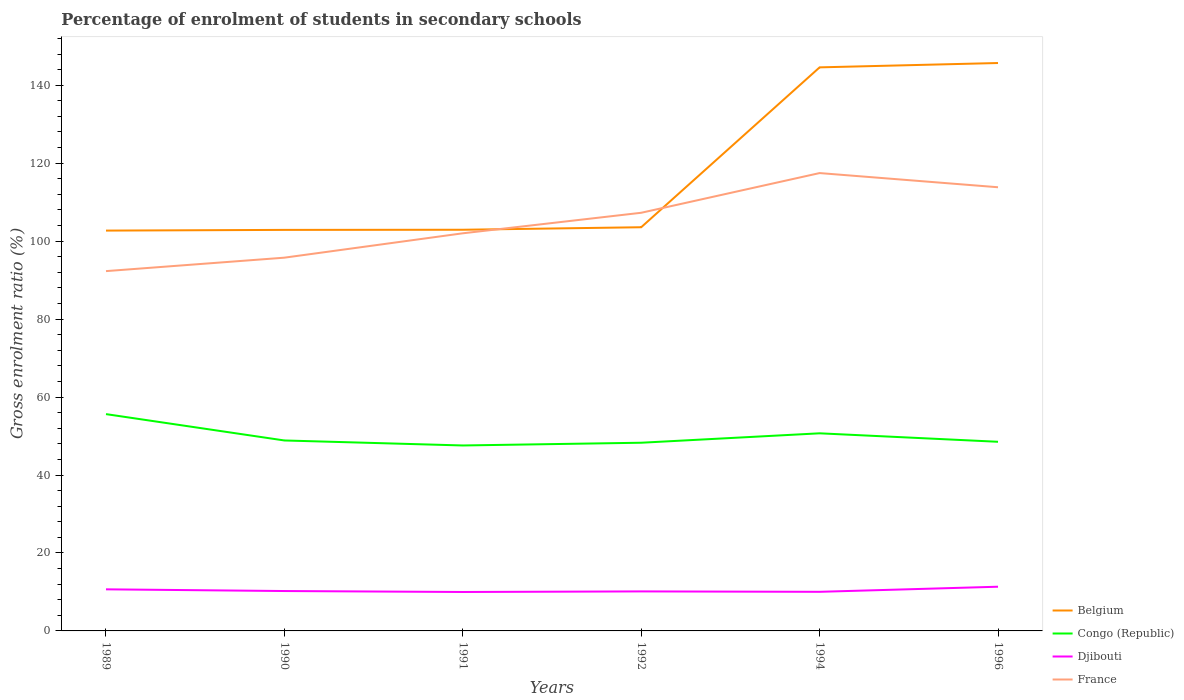How many different coloured lines are there?
Provide a succinct answer. 4. Does the line corresponding to Belgium intersect with the line corresponding to Djibouti?
Offer a very short reply. No. Is the number of lines equal to the number of legend labels?
Ensure brevity in your answer.  Yes. Across all years, what is the maximum percentage of students enrolled in secondary schools in Congo (Republic)?
Give a very brief answer. 47.58. In which year was the percentage of students enrolled in secondary schools in Djibouti maximum?
Your response must be concise. 1991. What is the total percentage of students enrolled in secondary schools in Djibouti in the graph?
Your answer should be very brief. -1.31. What is the difference between the highest and the second highest percentage of students enrolled in secondary schools in Djibouti?
Provide a short and direct response. 1.35. What is the difference between the highest and the lowest percentage of students enrolled in secondary schools in Belgium?
Provide a succinct answer. 2. How many years are there in the graph?
Your answer should be very brief. 6. What is the difference between two consecutive major ticks on the Y-axis?
Provide a short and direct response. 20. Are the values on the major ticks of Y-axis written in scientific E-notation?
Ensure brevity in your answer.  No. How many legend labels are there?
Your response must be concise. 4. What is the title of the graph?
Your answer should be very brief. Percentage of enrolment of students in secondary schools. Does "Poland" appear as one of the legend labels in the graph?
Offer a terse response. No. What is the label or title of the Y-axis?
Ensure brevity in your answer.  Gross enrolment ratio (%). What is the Gross enrolment ratio (%) of Belgium in 1989?
Ensure brevity in your answer.  102.7. What is the Gross enrolment ratio (%) in Congo (Republic) in 1989?
Provide a succinct answer. 55.62. What is the Gross enrolment ratio (%) in Djibouti in 1989?
Your answer should be compact. 10.67. What is the Gross enrolment ratio (%) of France in 1989?
Your response must be concise. 92.31. What is the Gross enrolment ratio (%) in Belgium in 1990?
Your response must be concise. 102.88. What is the Gross enrolment ratio (%) in Congo (Republic) in 1990?
Offer a very short reply. 48.86. What is the Gross enrolment ratio (%) of Djibouti in 1990?
Make the answer very short. 10.23. What is the Gross enrolment ratio (%) of France in 1990?
Your response must be concise. 95.76. What is the Gross enrolment ratio (%) of Belgium in 1991?
Ensure brevity in your answer.  102.92. What is the Gross enrolment ratio (%) in Congo (Republic) in 1991?
Provide a succinct answer. 47.58. What is the Gross enrolment ratio (%) of Djibouti in 1991?
Your answer should be compact. 9.99. What is the Gross enrolment ratio (%) of France in 1991?
Provide a succinct answer. 102.01. What is the Gross enrolment ratio (%) in Belgium in 1992?
Keep it short and to the point. 103.57. What is the Gross enrolment ratio (%) of Congo (Republic) in 1992?
Provide a succinct answer. 48.28. What is the Gross enrolment ratio (%) in Djibouti in 1992?
Your answer should be very brief. 10.14. What is the Gross enrolment ratio (%) of France in 1992?
Provide a short and direct response. 107.27. What is the Gross enrolment ratio (%) of Belgium in 1994?
Provide a succinct answer. 144.58. What is the Gross enrolment ratio (%) of Congo (Republic) in 1994?
Your response must be concise. 50.69. What is the Gross enrolment ratio (%) in Djibouti in 1994?
Provide a short and direct response. 10.03. What is the Gross enrolment ratio (%) of France in 1994?
Offer a very short reply. 117.46. What is the Gross enrolment ratio (%) of Belgium in 1996?
Make the answer very short. 145.69. What is the Gross enrolment ratio (%) of Congo (Republic) in 1996?
Ensure brevity in your answer.  48.52. What is the Gross enrolment ratio (%) in Djibouti in 1996?
Keep it short and to the point. 11.34. What is the Gross enrolment ratio (%) in France in 1996?
Ensure brevity in your answer.  113.82. Across all years, what is the maximum Gross enrolment ratio (%) in Belgium?
Ensure brevity in your answer.  145.69. Across all years, what is the maximum Gross enrolment ratio (%) of Congo (Republic)?
Provide a short and direct response. 55.62. Across all years, what is the maximum Gross enrolment ratio (%) of Djibouti?
Keep it short and to the point. 11.34. Across all years, what is the maximum Gross enrolment ratio (%) of France?
Offer a terse response. 117.46. Across all years, what is the minimum Gross enrolment ratio (%) in Belgium?
Offer a terse response. 102.7. Across all years, what is the minimum Gross enrolment ratio (%) in Congo (Republic)?
Ensure brevity in your answer.  47.58. Across all years, what is the minimum Gross enrolment ratio (%) of Djibouti?
Your answer should be very brief. 9.99. Across all years, what is the minimum Gross enrolment ratio (%) in France?
Make the answer very short. 92.31. What is the total Gross enrolment ratio (%) in Belgium in the graph?
Offer a very short reply. 702.34. What is the total Gross enrolment ratio (%) in Congo (Republic) in the graph?
Your answer should be very brief. 299.55. What is the total Gross enrolment ratio (%) of Djibouti in the graph?
Offer a very short reply. 62.41. What is the total Gross enrolment ratio (%) of France in the graph?
Offer a terse response. 628.63. What is the difference between the Gross enrolment ratio (%) of Belgium in 1989 and that in 1990?
Offer a very short reply. -0.18. What is the difference between the Gross enrolment ratio (%) of Congo (Republic) in 1989 and that in 1990?
Make the answer very short. 6.76. What is the difference between the Gross enrolment ratio (%) in Djibouti in 1989 and that in 1990?
Your response must be concise. 0.44. What is the difference between the Gross enrolment ratio (%) in France in 1989 and that in 1990?
Provide a succinct answer. -3.45. What is the difference between the Gross enrolment ratio (%) of Belgium in 1989 and that in 1991?
Offer a terse response. -0.21. What is the difference between the Gross enrolment ratio (%) of Congo (Republic) in 1989 and that in 1991?
Provide a short and direct response. 8.04. What is the difference between the Gross enrolment ratio (%) of Djibouti in 1989 and that in 1991?
Keep it short and to the point. 0.68. What is the difference between the Gross enrolment ratio (%) in France in 1989 and that in 1991?
Offer a very short reply. -9.7. What is the difference between the Gross enrolment ratio (%) in Belgium in 1989 and that in 1992?
Give a very brief answer. -0.86. What is the difference between the Gross enrolment ratio (%) of Congo (Republic) in 1989 and that in 1992?
Your answer should be compact. 7.34. What is the difference between the Gross enrolment ratio (%) of Djibouti in 1989 and that in 1992?
Offer a very short reply. 0.53. What is the difference between the Gross enrolment ratio (%) in France in 1989 and that in 1992?
Provide a succinct answer. -14.97. What is the difference between the Gross enrolment ratio (%) of Belgium in 1989 and that in 1994?
Your answer should be compact. -41.87. What is the difference between the Gross enrolment ratio (%) of Congo (Republic) in 1989 and that in 1994?
Your answer should be compact. 4.93. What is the difference between the Gross enrolment ratio (%) of Djibouti in 1989 and that in 1994?
Your answer should be compact. 0.64. What is the difference between the Gross enrolment ratio (%) of France in 1989 and that in 1994?
Your answer should be compact. -25.15. What is the difference between the Gross enrolment ratio (%) of Belgium in 1989 and that in 1996?
Your answer should be very brief. -42.99. What is the difference between the Gross enrolment ratio (%) in Congo (Republic) in 1989 and that in 1996?
Offer a terse response. 7.09. What is the difference between the Gross enrolment ratio (%) in Djibouti in 1989 and that in 1996?
Provide a succinct answer. -0.67. What is the difference between the Gross enrolment ratio (%) in France in 1989 and that in 1996?
Your answer should be very brief. -21.52. What is the difference between the Gross enrolment ratio (%) of Belgium in 1990 and that in 1991?
Make the answer very short. -0.04. What is the difference between the Gross enrolment ratio (%) in Congo (Republic) in 1990 and that in 1991?
Offer a very short reply. 1.28. What is the difference between the Gross enrolment ratio (%) of Djibouti in 1990 and that in 1991?
Your response must be concise. 0.24. What is the difference between the Gross enrolment ratio (%) in France in 1990 and that in 1991?
Keep it short and to the point. -6.25. What is the difference between the Gross enrolment ratio (%) in Belgium in 1990 and that in 1992?
Ensure brevity in your answer.  -0.68. What is the difference between the Gross enrolment ratio (%) in Congo (Republic) in 1990 and that in 1992?
Keep it short and to the point. 0.58. What is the difference between the Gross enrolment ratio (%) in Djibouti in 1990 and that in 1992?
Ensure brevity in your answer.  0.1. What is the difference between the Gross enrolment ratio (%) of France in 1990 and that in 1992?
Give a very brief answer. -11.52. What is the difference between the Gross enrolment ratio (%) in Belgium in 1990 and that in 1994?
Give a very brief answer. -41.7. What is the difference between the Gross enrolment ratio (%) in Congo (Republic) in 1990 and that in 1994?
Offer a very short reply. -1.83. What is the difference between the Gross enrolment ratio (%) of Djibouti in 1990 and that in 1994?
Keep it short and to the point. 0.2. What is the difference between the Gross enrolment ratio (%) in France in 1990 and that in 1994?
Your response must be concise. -21.7. What is the difference between the Gross enrolment ratio (%) in Belgium in 1990 and that in 1996?
Ensure brevity in your answer.  -42.81. What is the difference between the Gross enrolment ratio (%) in Congo (Republic) in 1990 and that in 1996?
Provide a short and direct response. 0.34. What is the difference between the Gross enrolment ratio (%) in Djibouti in 1990 and that in 1996?
Give a very brief answer. -1.11. What is the difference between the Gross enrolment ratio (%) in France in 1990 and that in 1996?
Make the answer very short. -18.07. What is the difference between the Gross enrolment ratio (%) in Belgium in 1991 and that in 1992?
Make the answer very short. -0.65. What is the difference between the Gross enrolment ratio (%) of Congo (Republic) in 1991 and that in 1992?
Offer a very short reply. -0.7. What is the difference between the Gross enrolment ratio (%) of Djibouti in 1991 and that in 1992?
Your response must be concise. -0.15. What is the difference between the Gross enrolment ratio (%) of France in 1991 and that in 1992?
Provide a short and direct response. -5.26. What is the difference between the Gross enrolment ratio (%) of Belgium in 1991 and that in 1994?
Your answer should be compact. -41.66. What is the difference between the Gross enrolment ratio (%) in Congo (Republic) in 1991 and that in 1994?
Provide a succinct answer. -3.12. What is the difference between the Gross enrolment ratio (%) of Djibouti in 1991 and that in 1994?
Provide a short and direct response. -0.04. What is the difference between the Gross enrolment ratio (%) of France in 1991 and that in 1994?
Provide a short and direct response. -15.45. What is the difference between the Gross enrolment ratio (%) of Belgium in 1991 and that in 1996?
Provide a short and direct response. -42.77. What is the difference between the Gross enrolment ratio (%) of Congo (Republic) in 1991 and that in 1996?
Your answer should be compact. -0.95. What is the difference between the Gross enrolment ratio (%) in Djibouti in 1991 and that in 1996?
Provide a succinct answer. -1.35. What is the difference between the Gross enrolment ratio (%) in France in 1991 and that in 1996?
Offer a terse response. -11.81. What is the difference between the Gross enrolment ratio (%) of Belgium in 1992 and that in 1994?
Your response must be concise. -41.01. What is the difference between the Gross enrolment ratio (%) of Congo (Republic) in 1992 and that in 1994?
Your answer should be very brief. -2.41. What is the difference between the Gross enrolment ratio (%) of Djibouti in 1992 and that in 1994?
Ensure brevity in your answer.  0.1. What is the difference between the Gross enrolment ratio (%) in France in 1992 and that in 1994?
Your response must be concise. -10.19. What is the difference between the Gross enrolment ratio (%) in Belgium in 1992 and that in 1996?
Ensure brevity in your answer.  -42.13. What is the difference between the Gross enrolment ratio (%) of Congo (Republic) in 1992 and that in 1996?
Make the answer very short. -0.25. What is the difference between the Gross enrolment ratio (%) in Djibouti in 1992 and that in 1996?
Offer a very short reply. -1.2. What is the difference between the Gross enrolment ratio (%) in France in 1992 and that in 1996?
Offer a very short reply. -6.55. What is the difference between the Gross enrolment ratio (%) of Belgium in 1994 and that in 1996?
Offer a terse response. -1.11. What is the difference between the Gross enrolment ratio (%) in Congo (Republic) in 1994 and that in 1996?
Keep it short and to the point. 2.17. What is the difference between the Gross enrolment ratio (%) in Djibouti in 1994 and that in 1996?
Your answer should be very brief. -1.31. What is the difference between the Gross enrolment ratio (%) in France in 1994 and that in 1996?
Ensure brevity in your answer.  3.64. What is the difference between the Gross enrolment ratio (%) in Belgium in 1989 and the Gross enrolment ratio (%) in Congo (Republic) in 1990?
Give a very brief answer. 53.84. What is the difference between the Gross enrolment ratio (%) in Belgium in 1989 and the Gross enrolment ratio (%) in Djibouti in 1990?
Your response must be concise. 92.47. What is the difference between the Gross enrolment ratio (%) of Belgium in 1989 and the Gross enrolment ratio (%) of France in 1990?
Provide a short and direct response. 6.95. What is the difference between the Gross enrolment ratio (%) of Congo (Republic) in 1989 and the Gross enrolment ratio (%) of Djibouti in 1990?
Keep it short and to the point. 45.38. What is the difference between the Gross enrolment ratio (%) in Congo (Republic) in 1989 and the Gross enrolment ratio (%) in France in 1990?
Your response must be concise. -40.14. What is the difference between the Gross enrolment ratio (%) of Djibouti in 1989 and the Gross enrolment ratio (%) of France in 1990?
Provide a short and direct response. -85.09. What is the difference between the Gross enrolment ratio (%) in Belgium in 1989 and the Gross enrolment ratio (%) in Congo (Republic) in 1991?
Ensure brevity in your answer.  55.13. What is the difference between the Gross enrolment ratio (%) of Belgium in 1989 and the Gross enrolment ratio (%) of Djibouti in 1991?
Your answer should be compact. 92.71. What is the difference between the Gross enrolment ratio (%) of Belgium in 1989 and the Gross enrolment ratio (%) of France in 1991?
Your answer should be compact. 0.7. What is the difference between the Gross enrolment ratio (%) of Congo (Republic) in 1989 and the Gross enrolment ratio (%) of Djibouti in 1991?
Ensure brevity in your answer.  45.63. What is the difference between the Gross enrolment ratio (%) in Congo (Republic) in 1989 and the Gross enrolment ratio (%) in France in 1991?
Your answer should be very brief. -46.39. What is the difference between the Gross enrolment ratio (%) in Djibouti in 1989 and the Gross enrolment ratio (%) in France in 1991?
Make the answer very short. -91.34. What is the difference between the Gross enrolment ratio (%) in Belgium in 1989 and the Gross enrolment ratio (%) in Congo (Republic) in 1992?
Provide a short and direct response. 54.42. What is the difference between the Gross enrolment ratio (%) in Belgium in 1989 and the Gross enrolment ratio (%) in Djibouti in 1992?
Provide a short and direct response. 92.57. What is the difference between the Gross enrolment ratio (%) of Belgium in 1989 and the Gross enrolment ratio (%) of France in 1992?
Ensure brevity in your answer.  -4.57. What is the difference between the Gross enrolment ratio (%) in Congo (Republic) in 1989 and the Gross enrolment ratio (%) in Djibouti in 1992?
Make the answer very short. 45.48. What is the difference between the Gross enrolment ratio (%) of Congo (Republic) in 1989 and the Gross enrolment ratio (%) of France in 1992?
Make the answer very short. -51.65. What is the difference between the Gross enrolment ratio (%) in Djibouti in 1989 and the Gross enrolment ratio (%) in France in 1992?
Give a very brief answer. -96.6. What is the difference between the Gross enrolment ratio (%) of Belgium in 1989 and the Gross enrolment ratio (%) of Congo (Republic) in 1994?
Keep it short and to the point. 52.01. What is the difference between the Gross enrolment ratio (%) in Belgium in 1989 and the Gross enrolment ratio (%) in Djibouti in 1994?
Your response must be concise. 92.67. What is the difference between the Gross enrolment ratio (%) in Belgium in 1989 and the Gross enrolment ratio (%) in France in 1994?
Provide a succinct answer. -14.76. What is the difference between the Gross enrolment ratio (%) of Congo (Republic) in 1989 and the Gross enrolment ratio (%) of Djibouti in 1994?
Your answer should be very brief. 45.59. What is the difference between the Gross enrolment ratio (%) of Congo (Republic) in 1989 and the Gross enrolment ratio (%) of France in 1994?
Provide a succinct answer. -61.84. What is the difference between the Gross enrolment ratio (%) in Djibouti in 1989 and the Gross enrolment ratio (%) in France in 1994?
Provide a short and direct response. -106.79. What is the difference between the Gross enrolment ratio (%) in Belgium in 1989 and the Gross enrolment ratio (%) in Congo (Republic) in 1996?
Provide a short and direct response. 54.18. What is the difference between the Gross enrolment ratio (%) of Belgium in 1989 and the Gross enrolment ratio (%) of Djibouti in 1996?
Your response must be concise. 91.36. What is the difference between the Gross enrolment ratio (%) in Belgium in 1989 and the Gross enrolment ratio (%) in France in 1996?
Make the answer very short. -11.12. What is the difference between the Gross enrolment ratio (%) of Congo (Republic) in 1989 and the Gross enrolment ratio (%) of Djibouti in 1996?
Keep it short and to the point. 44.28. What is the difference between the Gross enrolment ratio (%) in Congo (Republic) in 1989 and the Gross enrolment ratio (%) in France in 1996?
Your response must be concise. -58.2. What is the difference between the Gross enrolment ratio (%) in Djibouti in 1989 and the Gross enrolment ratio (%) in France in 1996?
Give a very brief answer. -103.15. What is the difference between the Gross enrolment ratio (%) in Belgium in 1990 and the Gross enrolment ratio (%) in Congo (Republic) in 1991?
Offer a very short reply. 55.31. What is the difference between the Gross enrolment ratio (%) of Belgium in 1990 and the Gross enrolment ratio (%) of Djibouti in 1991?
Offer a very short reply. 92.89. What is the difference between the Gross enrolment ratio (%) of Belgium in 1990 and the Gross enrolment ratio (%) of France in 1991?
Your answer should be compact. 0.87. What is the difference between the Gross enrolment ratio (%) in Congo (Republic) in 1990 and the Gross enrolment ratio (%) in Djibouti in 1991?
Make the answer very short. 38.87. What is the difference between the Gross enrolment ratio (%) of Congo (Republic) in 1990 and the Gross enrolment ratio (%) of France in 1991?
Your answer should be compact. -53.15. What is the difference between the Gross enrolment ratio (%) in Djibouti in 1990 and the Gross enrolment ratio (%) in France in 1991?
Provide a succinct answer. -91.77. What is the difference between the Gross enrolment ratio (%) of Belgium in 1990 and the Gross enrolment ratio (%) of Congo (Republic) in 1992?
Give a very brief answer. 54.6. What is the difference between the Gross enrolment ratio (%) in Belgium in 1990 and the Gross enrolment ratio (%) in Djibouti in 1992?
Make the answer very short. 92.74. What is the difference between the Gross enrolment ratio (%) in Belgium in 1990 and the Gross enrolment ratio (%) in France in 1992?
Your response must be concise. -4.39. What is the difference between the Gross enrolment ratio (%) in Congo (Republic) in 1990 and the Gross enrolment ratio (%) in Djibouti in 1992?
Give a very brief answer. 38.72. What is the difference between the Gross enrolment ratio (%) in Congo (Republic) in 1990 and the Gross enrolment ratio (%) in France in 1992?
Your answer should be very brief. -58.41. What is the difference between the Gross enrolment ratio (%) of Djibouti in 1990 and the Gross enrolment ratio (%) of France in 1992?
Give a very brief answer. -97.04. What is the difference between the Gross enrolment ratio (%) in Belgium in 1990 and the Gross enrolment ratio (%) in Congo (Republic) in 1994?
Your answer should be very brief. 52.19. What is the difference between the Gross enrolment ratio (%) of Belgium in 1990 and the Gross enrolment ratio (%) of Djibouti in 1994?
Provide a short and direct response. 92.85. What is the difference between the Gross enrolment ratio (%) of Belgium in 1990 and the Gross enrolment ratio (%) of France in 1994?
Your answer should be very brief. -14.58. What is the difference between the Gross enrolment ratio (%) of Congo (Republic) in 1990 and the Gross enrolment ratio (%) of Djibouti in 1994?
Provide a short and direct response. 38.83. What is the difference between the Gross enrolment ratio (%) in Congo (Republic) in 1990 and the Gross enrolment ratio (%) in France in 1994?
Provide a succinct answer. -68.6. What is the difference between the Gross enrolment ratio (%) of Djibouti in 1990 and the Gross enrolment ratio (%) of France in 1994?
Keep it short and to the point. -107.23. What is the difference between the Gross enrolment ratio (%) of Belgium in 1990 and the Gross enrolment ratio (%) of Congo (Republic) in 1996?
Ensure brevity in your answer.  54.36. What is the difference between the Gross enrolment ratio (%) of Belgium in 1990 and the Gross enrolment ratio (%) of Djibouti in 1996?
Make the answer very short. 91.54. What is the difference between the Gross enrolment ratio (%) of Belgium in 1990 and the Gross enrolment ratio (%) of France in 1996?
Your answer should be compact. -10.94. What is the difference between the Gross enrolment ratio (%) of Congo (Republic) in 1990 and the Gross enrolment ratio (%) of Djibouti in 1996?
Provide a succinct answer. 37.52. What is the difference between the Gross enrolment ratio (%) in Congo (Republic) in 1990 and the Gross enrolment ratio (%) in France in 1996?
Offer a terse response. -64.96. What is the difference between the Gross enrolment ratio (%) of Djibouti in 1990 and the Gross enrolment ratio (%) of France in 1996?
Your response must be concise. -103.59. What is the difference between the Gross enrolment ratio (%) in Belgium in 1991 and the Gross enrolment ratio (%) in Congo (Republic) in 1992?
Provide a short and direct response. 54.64. What is the difference between the Gross enrolment ratio (%) of Belgium in 1991 and the Gross enrolment ratio (%) of Djibouti in 1992?
Make the answer very short. 92.78. What is the difference between the Gross enrolment ratio (%) of Belgium in 1991 and the Gross enrolment ratio (%) of France in 1992?
Keep it short and to the point. -4.35. What is the difference between the Gross enrolment ratio (%) in Congo (Republic) in 1991 and the Gross enrolment ratio (%) in Djibouti in 1992?
Your answer should be compact. 37.44. What is the difference between the Gross enrolment ratio (%) of Congo (Republic) in 1991 and the Gross enrolment ratio (%) of France in 1992?
Your answer should be very brief. -59.7. What is the difference between the Gross enrolment ratio (%) of Djibouti in 1991 and the Gross enrolment ratio (%) of France in 1992?
Keep it short and to the point. -97.28. What is the difference between the Gross enrolment ratio (%) of Belgium in 1991 and the Gross enrolment ratio (%) of Congo (Republic) in 1994?
Your answer should be compact. 52.22. What is the difference between the Gross enrolment ratio (%) in Belgium in 1991 and the Gross enrolment ratio (%) in Djibouti in 1994?
Keep it short and to the point. 92.89. What is the difference between the Gross enrolment ratio (%) of Belgium in 1991 and the Gross enrolment ratio (%) of France in 1994?
Make the answer very short. -14.54. What is the difference between the Gross enrolment ratio (%) of Congo (Republic) in 1991 and the Gross enrolment ratio (%) of Djibouti in 1994?
Offer a terse response. 37.54. What is the difference between the Gross enrolment ratio (%) of Congo (Republic) in 1991 and the Gross enrolment ratio (%) of France in 1994?
Offer a very short reply. -69.88. What is the difference between the Gross enrolment ratio (%) of Djibouti in 1991 and the Gross enrolment ratio (%) of France in 1994?
Ensure brevity in your answer.  -107.47. What is the difference between the Gross enrolment ratio (%) of Belgium in 1991 and the Gross enrolment ratio (%) of Congo (Republic) in 1996?
Ensure brevity in your answer.  54.39. What is the difference between the Gross enrolment ratio (%) of Belgium in 1991 and the Gross enrolment ratio (%) of Djibouti in 1996?
Offer a very short reply. 91.58. What is the difference between the Gross enrolment ratio (%) in Belgium in 1991 and the Gross enrolment ratio (%) in France in 1996?
Offer a terse response. -10.9. What is the difference between the Gross enrolment ratio (%) in Congo (Republic) in 1991 and the Gross enrolment ratio (%) in Djibouti in 1996?
Offer a very short reply. 36.23. What is the difference between the Gross enrolment ratio (%) of Congo (Republic) in 1991 and the Gross enrolment ratio (%) of France in 1996?
Offer a terse response. -66.25. What is the difference between the Gross enrolment ratio (%) of Djibouti in 1991 and the Gross enrolment ratio (%) of France in 1996?
Your answer should be compact. -103.83. What is the difference between the Gross enrolment ratio (%) of Belgium in 1992 and the Gross enrolment ratio (%) of Congo (Republic) in 1994?
Provide a short and direct response. 52.87. What is the difference between the Gross enrolment ratio (%) of Belgium in 1992 and the Gross enrolment ratio (%) of Djibouti in 1994?
Offer a very short reply. 93.53. What is the difference between the Gross enrolment ratio (%) in Belgium in 1992 and the Gross enrolment ratio (%) in France in 1994?
Give a very brief answer. -13.89. What is the difference between the Gross enrolment ratio (%) of Congo (Republic) in 1992 and the Gross enrolment ratio (%) of Djibouti in 1994?
Offer a very short reply. 38.25. What is the difference between the Gross enrolment ratio (%) in Congo (Republic) in 1992 and the Gross enrolment ratio (%) in France in 1994?
Your answer should be compact. -69.18. What is the difference between the Gross enrolment ratio (%) of Djibouti in 1992 and the Gross enrolment ratio (%) of France in 1994?
Keep it short and to the point. -107.32. What is the difference between the Gross enrolment ratio (%) in Belgium in 1992 and the Gross enrolment ratio (%) in Congo (Republic) in 1996?
Offer a very short reply. 55.04. What is the difference between the Gross enrolment ratio (%) in Belgium in 1992 and the Gross enrolment ratio (%) in Djibouti in 1996?
Your response must be concise. 92.22. What is the difference between the Gross enrolment ratio (%) in Belgium in 1992 and the Gross enrolment ratio (%) in France in 1996?
Your response must be concise. -10.26. What is the difference between the Gross enrolment ratio (%) in Congo (Republic) in 1992 and the Gross enrolment ratio (%) in Djibouti in 1996?
Your response must be concise. 36.94. What is the difference between the Gross enrolment ratio (%) of Congo (Republic) in 1992 and the Gross enrolment ratio (%) of France in 1996?
Make the answer very short. -65.54. What is the difference between the Gross enrolment ratio (%) in Djibouti in 1992 and the Gross enrolment ratio (%) in France in 1996?
Your response must be concise. -103.68. What is the difference between the Gross enrolment ratio (%) in Belgium in 1994 and the Gross enrolment ratio (%) in Congo (Republic) in 1996?
Your answer should be very brief. 96.05. What is the difference between the Gross enrolment ratio (%) of Belgium in 1994 and the Gross enrolment ratio (%) of Djibouti in 1996?
Your answer should be compact. 133.24. What is the difference between the Gross enrolment ratio (%) of Belgium in 1994 and the Gross enrolment ratio (%) of France in 1996?
Provide a succinct answer. 30.76. What is the difference between the Gross enrolment ratio (%) in Congo (Republic) in 1994 and the Gross enrolment ratio (%) in Djibouti in 1996?
Your answer should be compact. 39.35. What is the difference between the Gross enrolment ratio (%) of Congo (Republic) in 1994 and the Gross enrolment ratio (%) of France in 1996?
Offer a terse response. -63.13. What is the difference between the Gross enrolment ratio (%) in Djibouti in 1994 and the Gross enrolment ratio (%) in France in 1996?
Offer a very short reply. -103.79. What is the average Gross enrolment ratio (%) of Belgium per year?
Keep it short and to the point. 117.06. What is the average Gross enrolment ratio (%) in Congo (Republic) per year?
Make the answer very short. 49.93. What is the average Gross enrolment ratio (%) of Djibouti per year?
Ensure brevity in your answer.  10.4. What is the average Gross enrolment ratio (%) of France per year?
Give a very brief answer. 104.77. In the year 1989, what is the difference between the Gross enrolment ratio (%) in Belgium and Gross enrolment ratio (%) in Congo (Republic)?
Your answer should be very brief. 47.08. In the year 1989, what is the difference between the Gross enrolment ratio (%) of Belgium and Gross enrolment ratio (%) of Djibouti?
Offer a very short reply. 92.03. In the year 1989, what is the difference between the Gross enrolment ratio (%) in Belgium and Gross enrolment ratio (%) in France?
Your answer should be compact. 10.4. In the year 1989, what is the difference between the Gross enrolment ratio (%) of Congo (Republic) and Gross enrolment ratio (%) of Djibouti?
Your answer should be very brief. 44.95. In the year 1989, what is the difference between the Gross enrolment ratio (%) in Congo (Republic) and Gross enrolment ratio (%) in France?
Your response must be concise. -36.69. In the year 1989, what is the difference between the Gross enrolment ratio (%) in Djibouti and Gross enrolment ratio (%) in France?
Your response must be concise. -81.64. In the year 1990, what is the difference between the Gross enrolment ratio (%) in Belgium and Gross enrolment ratio (%) in Congo (Republic)?
Keep it short and to the point. 54.02. In the year 1990, what is the difference between the Gross enrolment ratio (%) of Belgium and Gross enrolment ratio (%) of Djibouti?
Your answer should be compact. 92.65. In the year 1990, what is the difference between the Gross enrolment ratio (%) of Belgium and Gross enrolment ratio (%) of France?
Keep it short and to the point. 7.13. In the year 1990, what is the difference between the Gross enrolment ratio (%) in Congo (Republic) and Gross enrolment ratio (%) in Djibouti?
Offer a very short reply. 38.63. In the year 1990, what is the difference between the Gross enrolment ratio (%) of Congo (Republic) and Gross enrolment ratio (%) of France?
Offer a terse response. -46.9. In the year 1990, what is the difference between the Gross enrolment ratio (%) in Djibouti and Gross enrolment ratio (%) in France?
Your answer should be compact. -85.52. In the year 1991, what is the difference between the Gross enrolment ratio (%) in Belgium and Gross enrolment ratio (%) in Congo (Republic)?
Ensure brevity in your answer.  55.34. In the year 1991, what is the difference between the Gross enrolment ratio (%) of Belgium and Gross enrolment ratio (%) of Djibouti?
Give a very brief answer. 92.93. In the year 1991, what is the difference between the Gross enrolment ratio (%) in Belgium and Gross enrolment ratio (%) in France?
Your response must be concise. 0.91. In the year 1991, what is the difference between the Gross enrolment ratio (%) of Congo (Republic) and Gross enrolment ratio (%) of Djibouti?
Offer a very short reply. 37.58. In the year 1991, what is the difference between the Gross enrolment ratio (%) in Congo (Republic) and Gross enrolment ratio (%) in France?
Keep it short and to the point. -54.43. In the year 1991, what is the difference between the Gross enrolment ratio (%) in Djibouti and Gross enrolment ratio (%) in France?
Your answer should be very brief. -92.02. In the year 1992, what is the difference between the Gross enrolment ratio (%) in Belgium and Gross enrolment ratio (%) in Congo (Republic)?
Make the answer very short. 55.29. In the year 1992, what is the difference between the Gross enrolment ratio (%) of Belgium and Gross enrolment ratio (%) of Djibouti?
Ensure brevity in your answer.  93.43. In the year 1992, what is the difference between the Gross enrolment ratio (%) in Belgium and Gross enrolment ratio (%) in France?
Offer a very short reply. -3.71. In the year 1992, what is the difference between the Gross enrolment ratio (%) in Congo (Republic) and Gross enrolment ratio (%) in Djibouti?
Make the answer very short. 38.14. In the year 1992, what is the difference between the Gross enrolment ratio (%) in Congo (Republic) and Gross enrolment ratio (%) in France?
Provide a short and direct response. -58.99. In the year 1992, what is the difference between the Gross enrolment ratio (%) of Djibouti and Gross enrolment ratio (%) of France?
Your answer should be very brief. -97.14. In the year 1994, what is the difference between the Gross enrolment ratio (%) of Belgium and Gross enrolment ratio (%) of Congo (Republic)?
Your answer should be compact. 93.88. In the year 1994, what is the difference between the Gross enrolment ratio (%) of Belgium and Gross enrolment ratio (%) of Djibouti?
Ensure brevity in your answer.  134.54. In the year 1994, what is the difference between the Gross enrolment ratio (%) in Belgium and Gross enrolment ratio (%) in France?
Make the answer very short. 27.12. In the year 1994, what is the difference between the Gross enrolment ratio (%) in Congo (Republic) and Gross enrolment ratio (%) in Djibouti?
Offer a terse response. 40.66. In the year 1994, what is the difference between the Gross enrolment ratio (%) in Congo (Republic) and Gross enrolment ratio (%) in France?
Provide a succinct answer. -66.77. In the year 1994, what is the difference between the Gross enrolment ratio (%) of Djibouti and Gross enrolment ratio (%) of France?
Make the answer very short. -107.43. In the year 1996, what is the difference between the Gross enrolment ratio (%) in Belgium and Gross enrolment ratio (%) in Congo (Republic)?
Your answer should be very brief. 97.17. In the year 1996, what is the difference between the Gross enrolment ratio (%) in Belgium and Gross enrolment ratio (%) in Djibouti?
Offer a very short reply. 134.35. In the year 1996, what is the difference between the Gross enrolment ratio (%) in Belgium and Gross enrolment ratio (%) in France?
Provide a short and direct response. 31.87. In the year 1996, what is the difference between the Gross enrolment ratio (%) in Congo (Republic) and Gross enrolment ratio (%) in Djibouti?
Give a very brief answer. 37.18. In the year 1996, what is the difference between the Gross enrolment ratio (%) of Congo (Republic) and Gross enrolment ratio (%) of France?
Your answer should be very brief. -65.3. In the year 1996, what is the difference between the Gross enrolment ratio (%) of Djibouti and Gross enrolment ratio (%) of France?
Your answer should be compact. -102.48. What is the ratio of the Gross enrolment ratio (%) in Congo (Republic) in 1989 to that in 1990?
Offer a terse response. 1.14. What is the ratio of the Gross enrolment ratio (%) of Djibouti in 1989 to that in 1990?
Your answer should be compact. 1.04. What is the ratio of the Gross enrolment ratio (%) in France in 1989 to that in 1990?
Make the answer very short. 0.96. What is the ratio of the Gross enrolment ratio (%) in Belgium in 1989 to that in 1991?
Ensure brevity in your answer.  1. What is the ratio of the Gross enrolment ratio (%) in Congo (Republic) in 1989 to that in 1991?
Your answer should be very brief. 1.17. What is the ratio of the Gross enrolment ratio (%) of Djibouti in 1989 to that in 1991?
Offer a terse response. 1.07. What is the ratio of the Gross enrolment ratio (%) in France in 1989 to that in 1991?
Your response must be concise. 0.9. What is the ratio of the Gross enrolment ratio (%) in Belgium in 1989 to that in 1992?
Provide a succinct answer. 0.99. What is the ratio of the Gross enrolment ratio (%) in Congo (Republic) in 1989 to that in 1992?
Offer a terse response. 1.15. What is the ratio of the Gross enrolment ratio (%) in Djibouti in 1989 to that in 1992?
Ensure brevity in your answer.  1.05. What is the ratio of the Gross enrolment ratio (%) of France in 1989 to that in 1992?
Your answer should be very brief. 0.86. What is the ratio of the Gross enrolment ratio (%) in Belgium in 1989 to that in 1994?
Make the answer very short. 0.71. What is the ratio of the Gross enrolment ratio (%) in Congo (Republic) in 1989 to that in 1994?
Offer a terse response. 1.1. What is the ratio of the Gross enrolment ratio (%) in Djibouti in 1989 to that in 1994?
Offer a very short reply. 1.06. What is the ratio of the Gross enrolment ratio (%) of France in 1989 to that in 1994?
Make the answer very short. 0.79. What is the ratio of the Gross enrolment ratio (%) in Belgium in 1989 to that in 1996?
Keep it short and to the point. 0.7. What is the ratio of the Gross enrolment ratio (%) in Congo (Republic) in 1989 to that in 1996?
Keep it short and to the point. 1.15. What is the ratio of the Gross enrolment ratio (%) in Djibouti in 1989 to that in 1996?
Keep it short and to the point. 0.94. What is the ratio of the Gross enrolment ratio (%) in France in 1989 to that in 1996?
Give a very brief answer. 0.81. What is the ratio of the Gross enrolment ratio (%) of Djibouti in 1990 to that in 1991?
Provide a short and direct response. 1.02. What is the ratio of the Gross enrolment ratio (%) of France in 1990 to that in 1991?
Provide a short and direct response. 0.94. What is the ratio of the Gross enrolment ratio (%) in Djibouti in 1990 to that in 1992?
Offer a terse response. 1.01. What is the ratio of the Gross enrolment ratio (%) of France in 1990 to that in 1992?
Provide a short and direct response. 0.89. What is the ratio of the Gross enrolment ratio (%) of Belgium in 1990 to that in 1994?
Your response must be concise. 0.71. What is the ratio of the Gross enrolment ratio (%) of Congo (Republic) in 1990 to that in 1994?
Your response must be concise. 0.96. What is the ratio of the Gross enrolment ratio (%) of Djibouti in 1990 to that in 1994?
Give a very brief answer. 1.02. What is the ratio of the Gross enrolment ratio (%) of France in 1990 to that in 1994?
Provide a short and direct response. 0.82. What is the ratio of the Gross enrolment ratio (%) in Belgium in 1990 to that in 1996?
Make the answer very short. 0.71. What is the ratio of the Gross enrolment ratio (%) of Congo (Republic) in 1990 to that in 1996?
Your answer should be very brief. 1.01. What is the ratio of the Gross enrolment ratio (%) of Djibouti in 1990 to that in 1996?
Offer a very short reply. 0.9. What is the ratio of the Gross enrolment ratio (%) in France in 1990 to that in 1996?
Provide a short and direct response. 0.84. What is the ratio of the Gross enrolment ratio (%) of Belgium in 1991 to that in 1992?
Provide a short and direct response. 0.99. What is the ratio of the Gross enrolment ratio (%) of Congo (Republic) in 1991 to that in 1992?
Your answer should be compact. 0.99. What is the ratio of the Gross enrolment ratio (%) in Djibouti in 1991 to that in 1992?
Your answer should be compact. 0.99. What is the ratio of the Gross enrolment ratio (%) of France in 1991 to that in 1992?
Your response must be concise. 0.95. What is the ratio of the Gross enrolment ratio (%) in Belgium in 1991 to that in 1994?
Make the answer very short. 0.71. What is the ratio of the Gross enrolment ratio (%) in Congo (Republic) in 1991 to that in 1994?
Keep it short and to the point. 0.94. What is the ratio of the Gross enrolment ratio (%) in Djibouti in 1991 to that in 1994?
Provide a short and direct response. 1. What is the ratio of the Gross enrolment ratio (%) in France in 1991 to that in 1994?
Ensure brevity in your answer.  0.87. What is the ratio of the Gross enrolment ratio (%) of Belgium in 1991 to that in 1996?
Your answer should be very brief. 0.71. What is the ratio of the Gross enrolment ratio (%) in Congo (Republic) in 1991 to that in 1996?
Offer a very short reply. 0.98. What is the ratio of the Gross enrolment ratio (%) in Djibouti in 1991 to that in 1996?
Your answer should be very brief. 0.88. What is the ratio of the Gross enrolment ratio (%) in France in 1991 to that in 1996?
Ensure brevity in your answer.  0.9. What is the ratio of the Gross enrolment ratio (%) of Belgium in 1992 to that in 1994?
Your answer should be compact. 0.72. What is the ratio of the Gross enrolment ratio (%) of Congo (Republic) in 1992 to that in 1994?
Provide a succinct answer. 0.95. What is the ratio of the Gross enrolment ratio (%) of Djibouti in 1992 to that in 1994?
Your response must be concise. 1.01. What is the ratio of the Gross enrolment ratio (%) in France in 1992 to that in 1994?
Offer a terse response. 0.91. What is the ratio of the Gross enrolment ratio (%) in Belgium in 1992 to that in 1996?
Give a very brief answer. 0.71. What is the ratio of the Gross enrolment ratio (%) of Congo (Republic) in 1992 to that in 1996?
Give a very brief answer. 0.99. What is the ratio of the Gross enrolment ratio (%) in Djibouti in 1992 to that in 1996?
Make the answer very short. 0.89. What is the ratio of the Gross enrolment ratio (%) of France in 1992 to that in 1996?
Your answer should be very brief. 0.94. What is the ratio of the Gross enrolment ratio (%) in Belgium in 1994 to that in 1996?
Give a very brief answer. 0.99. What is the ratio of the Gross enrolment ratio (%) of Congo (Republic) in 1994 to that in 1996?
Offer a terse response. 1.04. What is the ratio of the Gross enrolment ratio (%) of Djibouti in 1994 to that in 1996?
Offer a very short reply. 0.88. What is the ratio of the Gross enrolment ratio (%) in France in 1994 to that in 1996?
Your answer should be compact. 1.03. What is the difference between the highest and the second highest Gross enrolment ratio (%) in Belgium?
Offer a very short reply. 1.11. What is the difference between the highest and the second highest Gross enrolment ratio (%) in Congo (Republic)?
Keep it short and to the point. 4.93. What is the difference between the highest and the second highest Gross enrolment ratio (%) of Djibouti?
Give a very brief answer. 0.67. What is the difference between the highest and the second highest Gross enrolment ratio (%) of France?
Give a very brief answer. 3.64. What is the difference between the highest and the lowest Gross enrolment ratio (%) in Belgium?
Make the answer very short. 42.99. What is the difference between the highest and the lowest Gross enrolment ratio (%) in Congo (Republic)?
Give a very brief answer. 8.04. What is the difference between the highest and the lowest Gross enrolment ratio (%) of Djibouti?
Make the answer very short. 1.35. What is the difference between the highest and the lowest Gross enrolment ratio (%) of France?
Offer a very short reply. 25.15. 